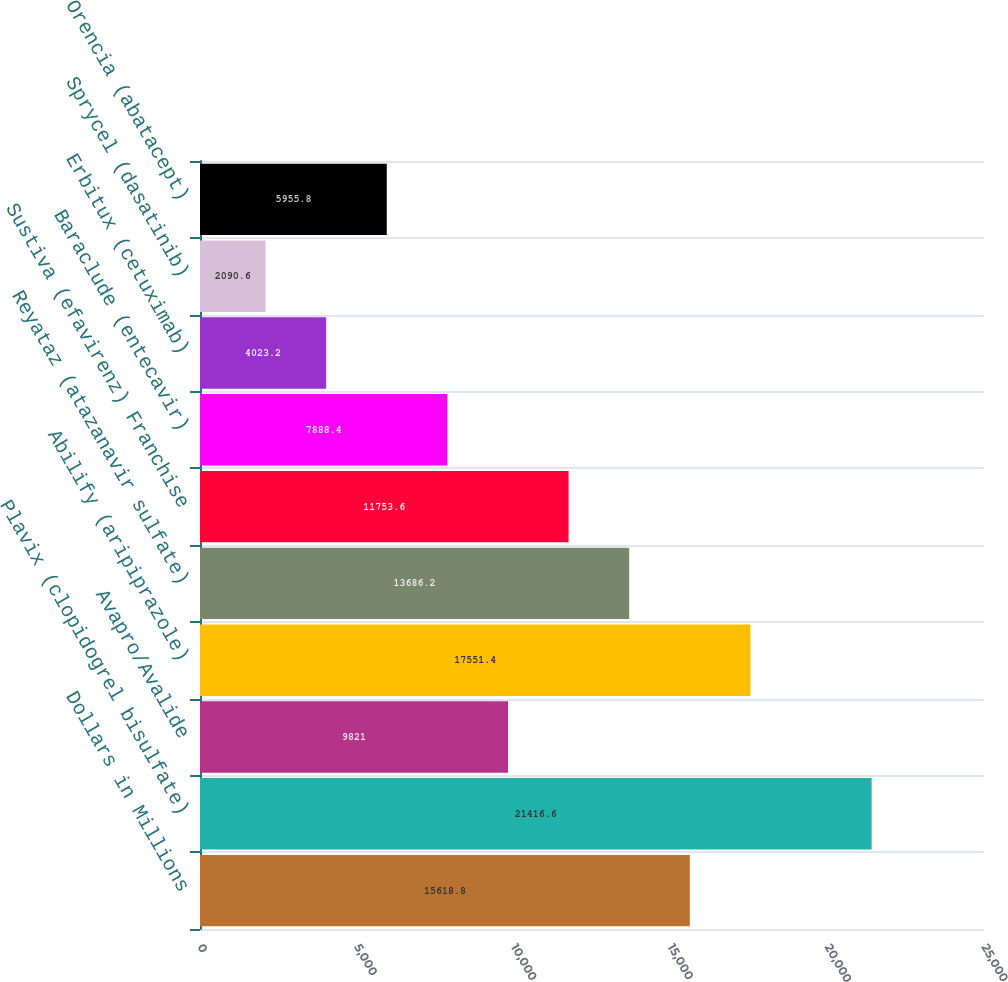Convert chart. <chart><loc_0><loc_0><loc_500><loc_500><bar_chart><fcel>Dollars in Millions<fcel>Plavix (clopidogrel bisulfate)<fcel>Avapro/Avalide<fcel>Abilify (aripiprazole)<fcel>Reyataz (atazanavir sulfate)<fcel>Sustiva (efavirenz) Franchise<fcel>Baraclude (entecavir)<fcel>Erbitux (cetuximab)<fcel>Sprycel (dasatinib)<fcel>Orencia (abatacept)<nl><fcel>15618.8<fcel>21416.6<fcel>9821<fcel>17551.4<fcel>13686.2<fcel>11753.6<fcel>7888.4<fcel>4023.2<fcel>2090.6<fcel>5955.8<nl></chart> 